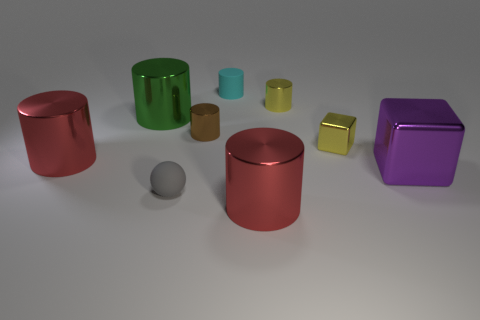What can you infer about the relative weights of the objects based on their materials? Given that the objects appear to be made of different materials, like metallic for the cylinders and cubes and more matte for the spheres, one might infer that the metallic objects would generally be heavier than the matte spheres assuming the materials are standard metals and plastics respectively. 